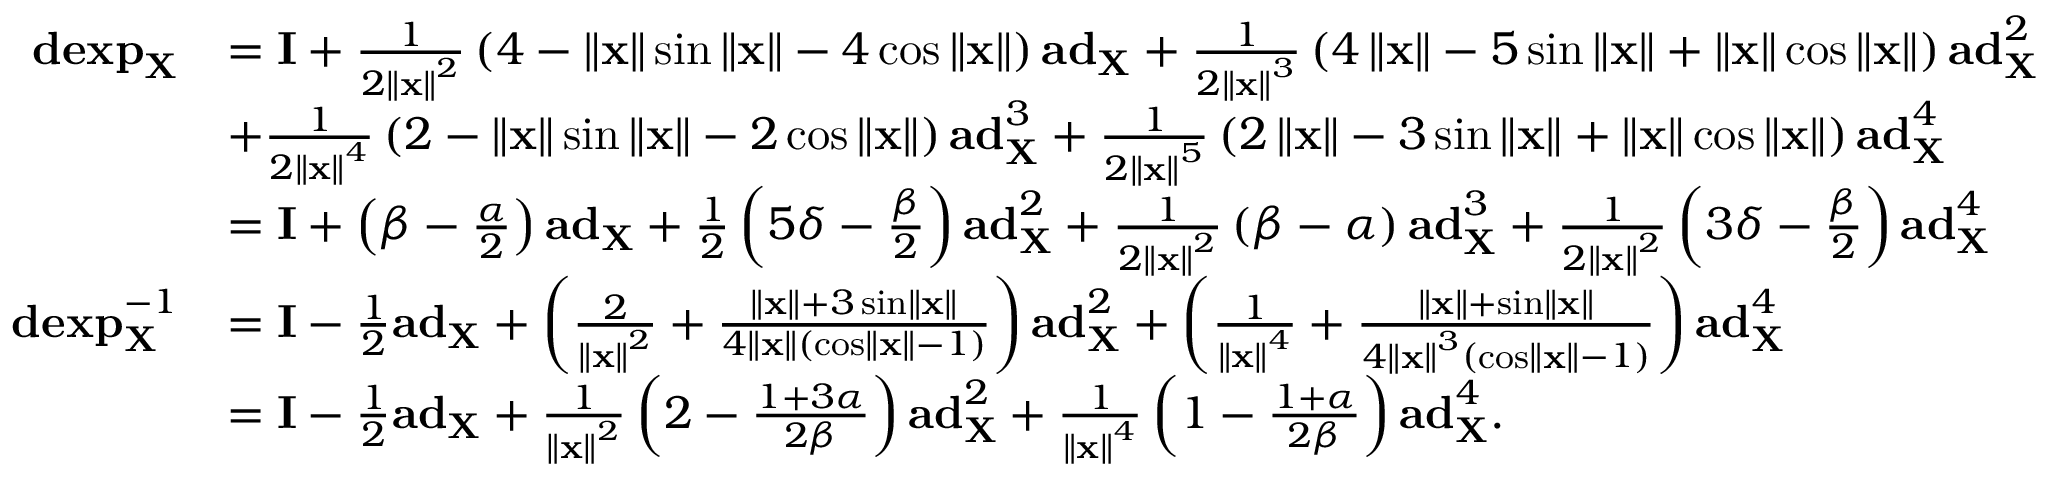<formula> <loc_0><loc_0><loc_500><loc_500>\begin{array} { r l } { d e x p _ { X } } & { = I + \frac { 1 } { 2 \left \| x \right \| ^ { 2 } } \left ( 4 - \left \| x \right \| \sin \left \| x \right \| - 4 \cos \left \| x \right \| \right ) a d _ { X } + \frac { 1 } { 2 \left \| x \right \| ^ { 3 } } \left ( 4 \left \| x \right \| - 5 \sin \left \| x \right \| + \left \| x \right \| \cos \left \| x \right \| \right ) a d _ { X } ^ { 2 } } \\ & { + \frac { 1 } { 2 \left \| x \right \| ^ { 4 } } \left ( 2 - \left \| x \right \| \sin \left \| x \right \| - 2 \cos \left \| x \right \| \right ) a d _ { X } ^ { 3 } + \frac { 1 } { 2 \left \| x \right \| ^ { 5 } } \left ( 2 \left \| x \right \| - 3 \sin \left \| x \right \| + \left \| x \right \| \cos \left \| x \right \| \right ) a d _ { X } ^ { 4 } } \\ & { = I + \left ( \beta - \frac { \alpha } { 2 } \right ) a d _ { X } + \frac { 1 } { 2 } \left ( 5 \delta - \frac { \beta } { 2 } \right ) a d _ { X } ^ { 2 } + \frac { 1 } { 2 \left \| x \right \| ^ { 2 } } \left ( \beta - \alpha \right ) a d _ { X } ^ { 3 } + \frac { 1 } { 2 \left \| x \right \| ^ { 2 } } \left ( 3 \delta - \frac { \beta } { 2 } \right ) a d _ { X } ^ { 4 } } \\ { d e x p _ { X } ^ { - 1 } } & { = I - \frac { 1 } { 2 } a d _ { X } + \left ( \frac { 2 } { \left \| x \right \| ^ { 2 } } + \frac { \left \| x \right \| + 3 \sin \left \| x \right \| } { 4 \left \| x \right \| \left ( \cos \left \| x \right \| - 1 \right ) } \right ) a d _ { X } ^ { 2 } + \left ( \frac { 1 } { \left \| x \right \| ^ { 4 } } + \frac { \left \| x \right \| + \sin \left \| x \right \| } { 4 \left \| x \right \| ^ { 3 } \left ( \cos \left \| x \right \| - 1 \right ) } \right ) a d _ { X } ^ { 4 } } \\ & { = I - \frac { 1 } { 2 } a d _ { X } + \frac { 1 } { \left \| x \right \| ^ { 2 } } \left ( 2 - \frac { 1 + 3 \alpha } { 2 \beta } \right ) a d _ { X } ^ { 2 } + \frac { 1 } { \left \| x \right \| ^ { 4 } } \left ( 1 - \frac { 1 + \alpha } { 2 \beta } \right ) a d _ { X } ^ { 4 } . } \end{array}</formula> 